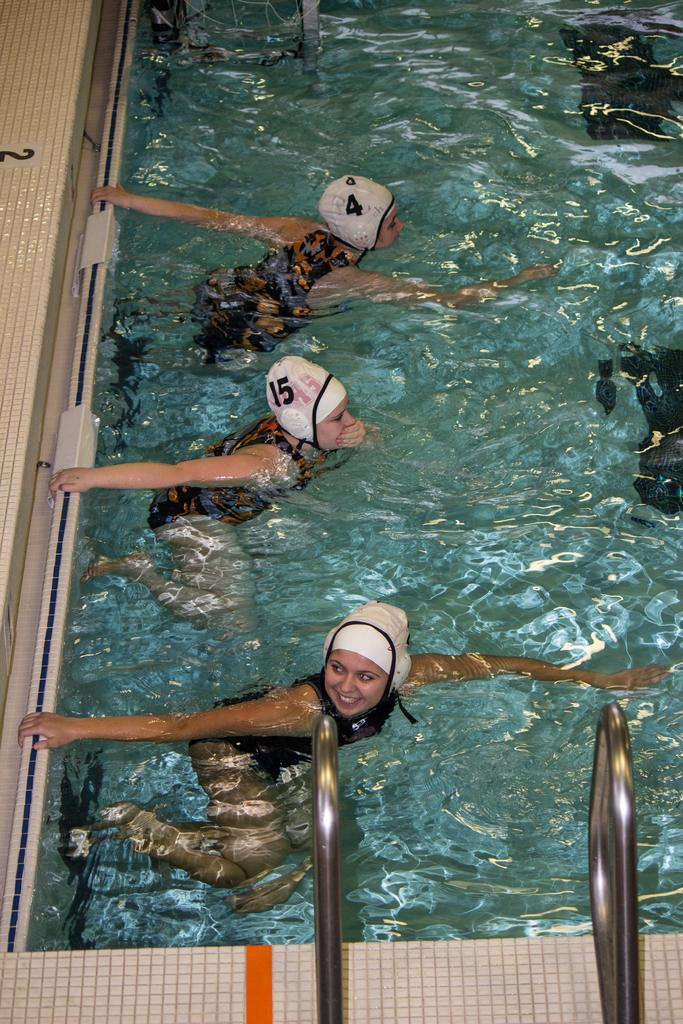What is visible in the image? Water is visible in the image. How many people are in the water? There are three people in the water. What are the people wearing on their heads? The people are wearing caps. What feature can be seen on the side of the image? There are handles on the side of the image. Can you see any twigs floating in the water in the image? There is no mention of twigs in the image, so it cannot be determined if any are present. What type of thrill are the people experiencing in the water? The image does not provide information about the people's emotions or experiences, so it cannot be determined if they are experiencing any thrill. 